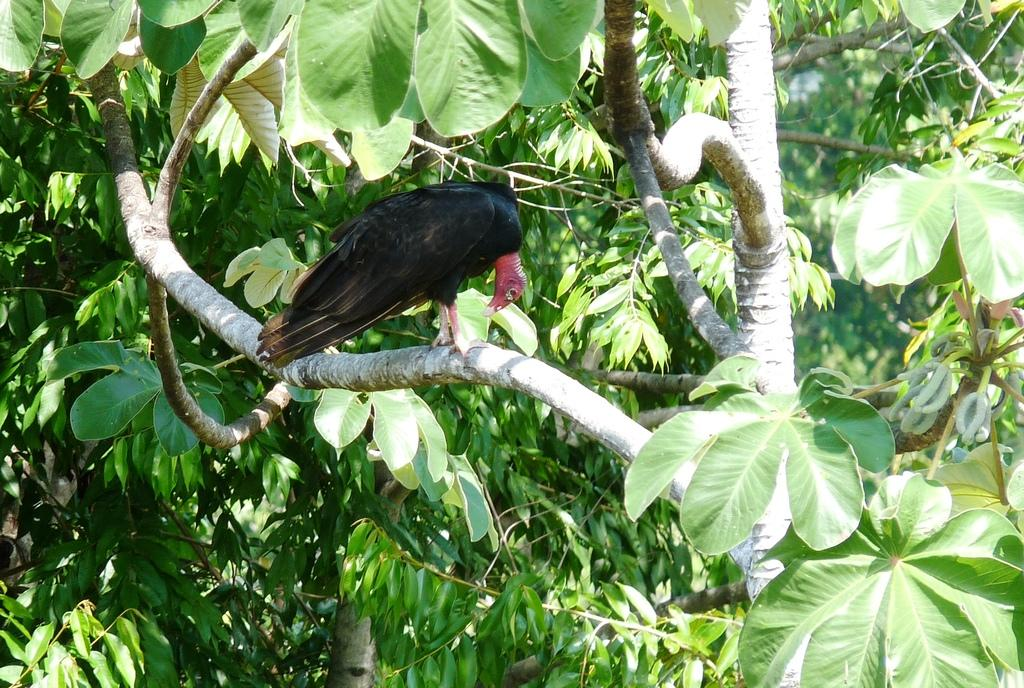What type of animal is in the image? There is a bird in the image. Where is the bird located? The bird is sitting on a branch. What can be seen in the background of the image? There are green leaves in the image. What type of hose is visible in the image? There is no hose present in the image. What channel is the bird watching in the image? The image does not depict the bird watching a channel, as it is sitting on a branch with green leaves in the background. 